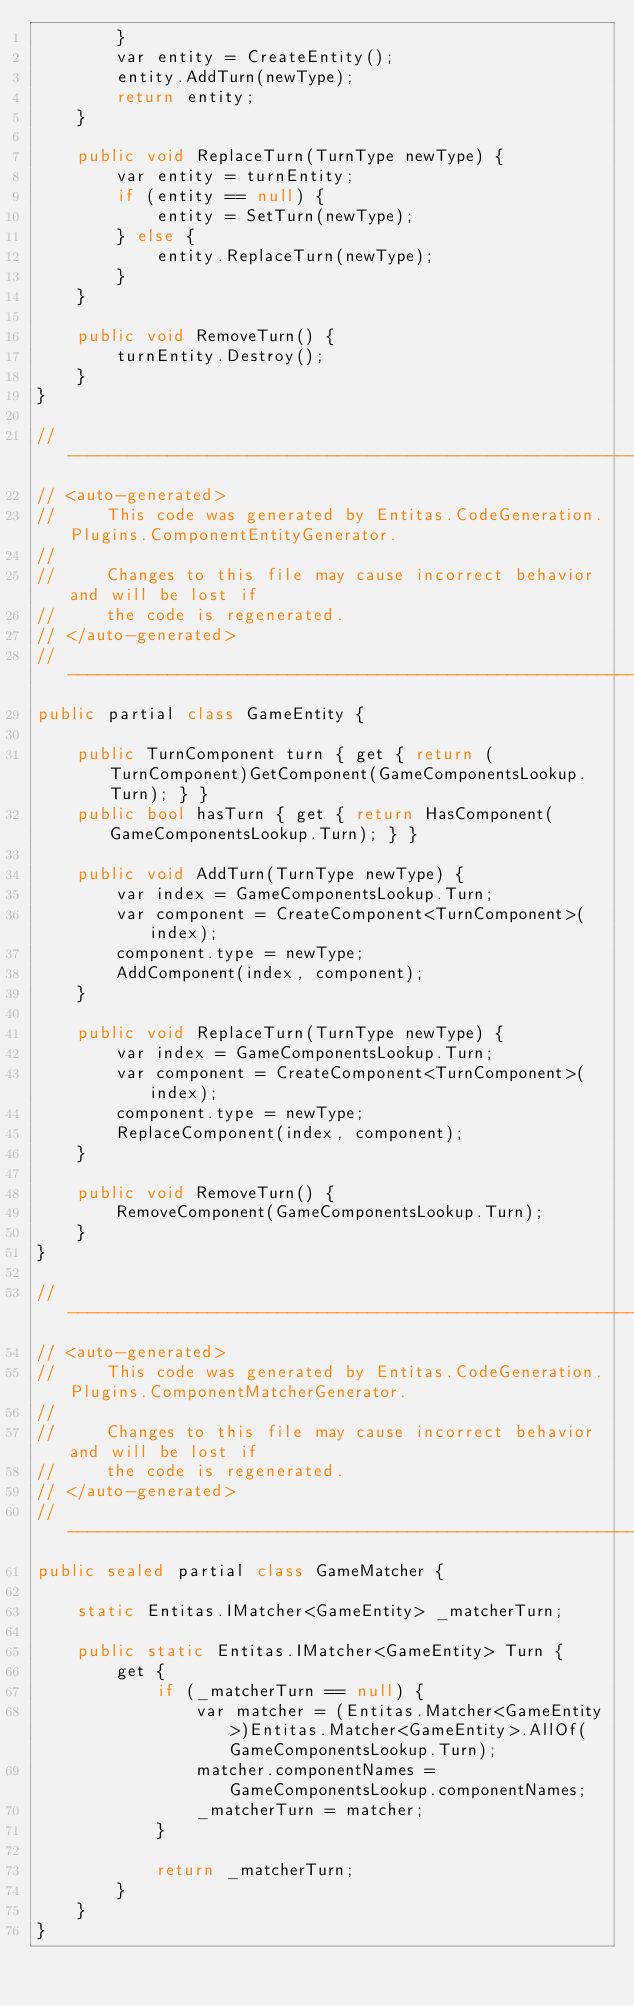Convert code to text. <code><loc_0><loc_0><loc_500><loc_500><_C#_>        }
        var entity = CreateEntity();
        entity.AddTurn(newType);
        return entity;
    }

    public void ReplaceTurn(TurnType newType) {
        var entity = turnEntity;
        if (entity == null) {
            entity = SetTurn(newType);
        } else {
            entity.ReplaceTurn(newType);
        }
    }

    public void RemoveTurn() {
        turnEntity.Destroy();
    }
}

//------------------------------------------------------------------------------
// <auto-generated>
//     This code was generated by Entitas.CodeGeneration.Plugins.ComponentEntityGenerator.
//
//     Changes to this file may cause incorrect behavior and will be lost if
//     the code is regenerated.
// </auto-generated>
//------------------------------------------------------------------------------
public partial class GameEntity {

    public TurnComponent turn { get { return (TurnComponent)GetComponent(GameComponentsLookup.Turn); } }
    public bool hasTurn { get { return HasComponent(GameComponentsLookup.Turn); } }

    public void AddTurn(TurnType newType) {
        var index = GameComponentsLookup.Turn;
        var component = CreateComponent<TurnComponent>(index);
        component.type = newType;
        AddComponent(index, component);
    }

    public void ReplaceTurn(TurnType newType) {
        var index = GameComponentsLookup.Turn;
        var component = CreateComponent<TurnComponent>(index);
        component.type = newType;
        ReplaceComponent(index, component);
    }

    public void RemoveTurn() {
        RemoveComponent(GameComponentsLookup.Turn);
    }
}

//------------------------------------------------------------------------------
// <auto-generated>
//     This code was generated by Entitas.CodeGeneration.Plugins.ComponentMatcherGenerator.
//
//     Changes to this file may cause incorrect behavior and will be lost if
//     the code is regenerated.
// </auto-generated>
//------------------------------------------------------------------------------
public sealed partial class GameMatcher {

    static Entitas.IMatcher<GameEntity> _matcherTurn;

    public static Entitas.IMatcher<GameEntity> Turn {
        get {
            if (_matcherTurn == null) {
                var matcher = (Entitas.Matcher<GameEntity>)Entitas.Matcher<GameEntity>.AllOf(GameComponentsLookup.Turn);
                matcher.componentNames = GameComponentsLookup.componentNames;
                _matcherTurn = matcher;
            }

            return _matcherTurn;
        }
    }
}
</code> 